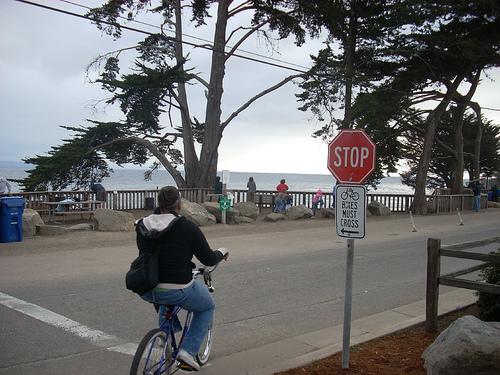What must cross?
Keep it brief. Bikes. How many trees are there?
Be succinct. 5. What is the man riding?
Write a very short answer. Bike. What is she riding on?
Concise answer only. Bike. 